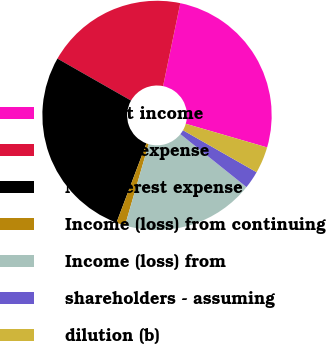Convert chart. <chart><loc_0><loc_0><loc_500><loc_500><pie_chart><fcel>Interest income<fcel>Interest expense<fcel>Noninterest expense<fcel>Income (loss) from continuing<fcel>Income (loss) from<fcel>shareholders - assuming<fcel>dilution (b)<nl><fcel>26.25%<fcel>20.0%<fcel>27.5%<fcel>1.25%<fcel>18.75%<fcel>2.5%<fcel>3.75%<nl></chart> 